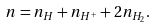<formula> <loc_0><loc_0><loc_500><loc_500>n = n _ { H } + n _ { H ^ { + } } + 2 n _ { H _ { 2 } } .</formula> 